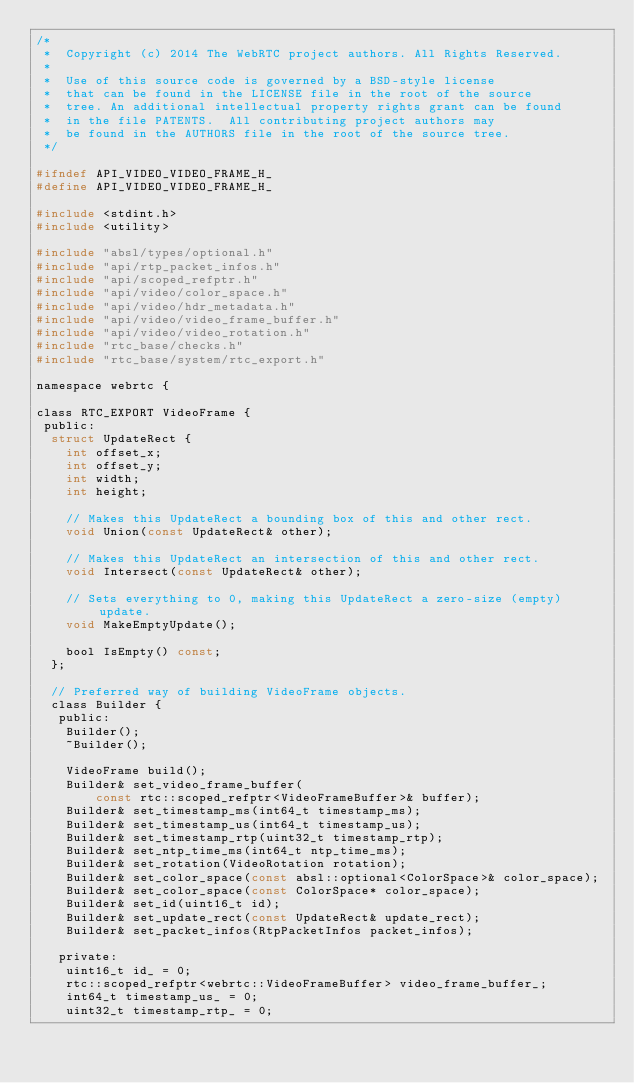Convert code to text. <code><loc_0><loc_0><loc_500><loc_500><_C_>/*
 *  Copyright (c) 2014 The WebRTC project authors. All Rights Reserved.
 *
 *  Use of this source code is governed by a BSD-style license
 *  that can be found in the LICENSE file in the root of the source
 *  tree. An additional intellectual property rights grant can be found
 *  in the file PATENTS.  All contributing project authors may
 *  be found in the AUTHORS file in the root of the source tree.
 */

#ifndef API_VIDEO_VIDEO_FRAME_H_
#define API_VIDEO_VIDEO_FRAME_H_

#include <stdint.h>
#include <utility>

#include "absl/types/optional.h"
#include "api/rtp_packet_infos.h"
#include "api/scoped_refptr.h"
#include "api/video/color_space.h"
#include "api/video/hdr_metadata.h"
#include "api/video/video_frame_buffer.h"
#include "api/video/video_rotation.h"
#include "rtc_base/checks.h"
#include "rtc_base/system/rtc_export.h"

namespace webrtc {

class RTC_EXPORT VideoFrame {
 public:
  struct UpdateRect {
    int offset_x;
    int offset_y;
    int width;
    int height;

    // Makes this UpdateRect a bounding box of this and other rect.
    void Union(const UpdateRect& other);

    // Makes this UpdateRect an intersection of this and other rect.
    void Intersect(const UpdateRect& other);

    // Sets everything to 0, making this UpdateRect a zero-size (empty) update.
    void MakeEmptyUpdate();

    bool IsEmpty() const;
  };

  // Preferred way of building VideoFrame objects.
  class Builder {
   public:
    Builder();
    ~Builder();

    VideoFrame build();
    Builder& set_video_frame_buffer(
        const rtc::scoped_refptr<VideoFrameBuffer>& buffer);
    Builder& set_timestamp_ms(int64_t timestamp_ms);
    Builder& set_timestamp_us(int64_t timestamp_us);
    Builder& set_timestamp_rtp(uint32_t timestamp_rtp);
    Builder& set_ntp_time_ms(int64_t ntp_time_ms);
    Builder& set_rotation(VideoRotation rotation);
    Builder& set_color_space(const absl::optional<ColorSpace>& color_space);
    Builder& set_color_space(const ColorSpace* color_space);
    Builder& set_id(uint16_t id);
    Builder& set_update_rect(const UpdateRect& update_rect);
    Builder& set_packet_infos(RtpPacketInfos packet_infos);

   private:
    uint16_t id_ = 0;
    rtc::scoped_refptr<webrtc::VideoFrameBuffer> video_frame_buffer_;
    int64_t timestamp_us_ = 0;
    uint32_t timestamp_rtp_ = 0;</code> 